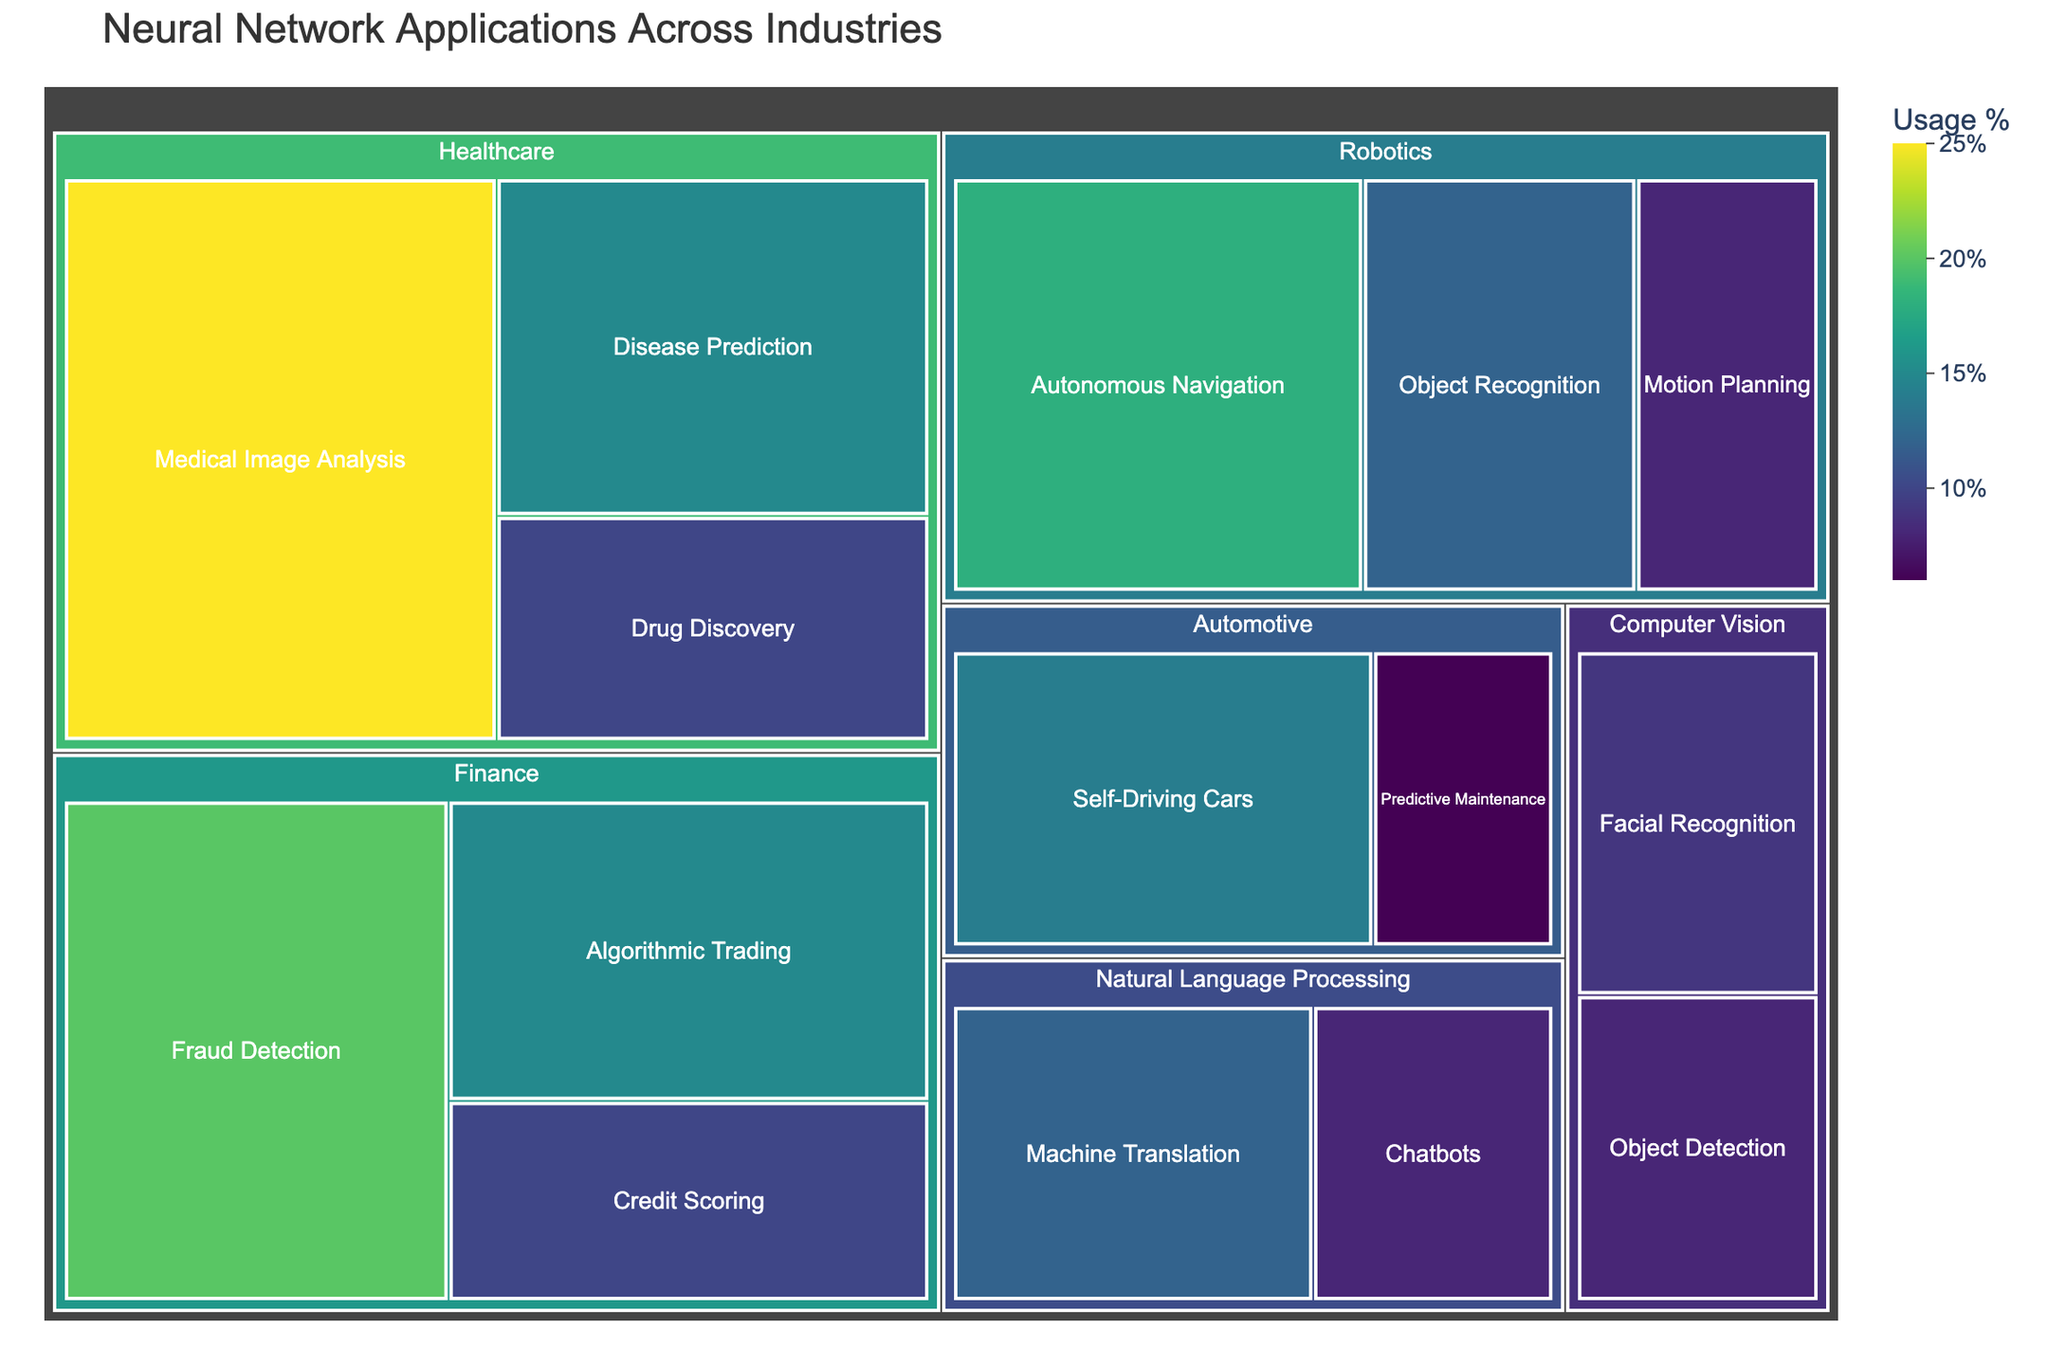How many application categories are there in the finance industry? First, locate the 'Finance' section in the treemap. Under this section, count the different subcategories listed.
Answer: 3 What is the total usage percentage of neural network applications in the healthcare industry? Identify the usage percentages for all applications under 'Healthcare': Medical Image Analysis (25%), Disease Prediction (15%), and Drug Discovery (10%). Sum these percentages.
Answer: 50% Which application has the highest usage percentage across all industries? Scan through all categories and subcategories, comparing their usage percentages. The highest value is Medical Image Analysis under Healthcare at 25%.
Answer: Medical Image Analysis Which industry has the least diverse set of applications? Compare the number of different applications under each industry section. Identify the one with the fewest number of applications. 'Automotive' has two applications (Self-Driving Cars and Predictive Maintenance).
Answer: Automotive Is Fraud Detection more widely used than Disease Prediction? Compare the usage percentages of Fraud Detection and Disease Prediction. Fraud Detection has 20%, whereas Disease Prediction has 15%.
Answer: Yes Which industry has the highest total usage percentage, combining all its applications? Sum up the usage percentages of applications under each industry: Healthcare (50%), Finance (45%), Robotics (38%), Automotive (20%), Natural Language Processing (20%), and Computer Vision (17%).
Answer: Healthcare What is the difference in usage percentage between Algorithmic Trading and Credit Scoring? Identify the usage percentages from the Finance section: Algorithmic Trading (15%) and Credit Scoring (10%). Subtract the smaller value from the larger one: 15% - 10% = 5%.
Answer: 5% What is the average usage percentage of applications in the Natural Language Processing industry? Find the usage percentages of applications under Natural Language Processing: Machine Translation (12%) and Chatbots (8%). Calculate the average: (12% + 8%) / 2 = 10%.
Answer: 10% Are Autonomous Navigation and Object Recognition more widely used than Motion Planning combined? Sum the usage percentages of Autonomous Navigation (18%) and Object Recognition (12%) for a total of 30%. Compare this to 8% for Motion Planning. 30% > 8%, thus combined usage is higher.
Answer: Yes 